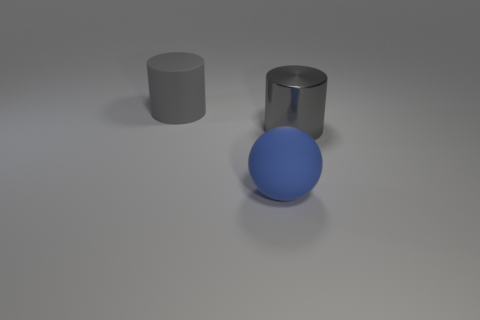Is there anything else that has the same shape as the blue thing?
Your answer should be compact. No. What size is the matte cylinder that is the same color as the big metallic cylinder?
Make the answer very short. Large. What size is the cylinder that is the same material as the large ball?
Your answer should be very brief. Large. What shape is the big rubber object that is in front of the cylinder that is on the right side of the rubber object to the right of the gray rubber object?
Ensure brevity in your answer.  Sphere. Are there fewer gray cylinders that are right of the shiny cylinder than large blue objects to the left of the sphere?
Your answer should be compact. No. There is a big thing that is to the right of the large rubber object that is in front of the gray matte thing; what shape is it?
Make the answer very short. Cylinder. Are there any other things of the same color as the rubber ball?
Provide a short and direct response. No. Is the metal object the same color as the large ball?
Your answer should be very brief. No. What number of purple objects are rubber objects or cylinders?
Your answer should be compact. 0. Are there fewer big gray rubber things that are to the right of the gray shiny cylinder than large blue metallic balls?
Give a very brief answer. No. 